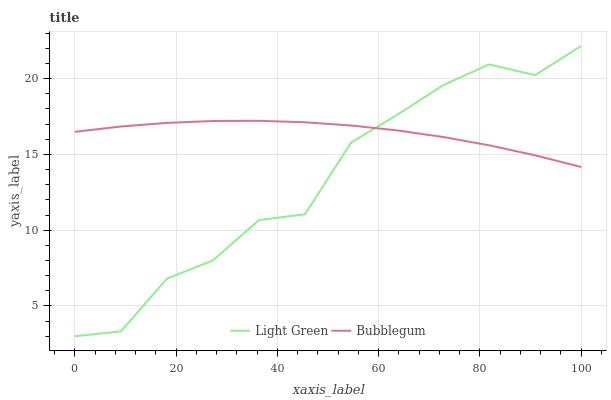Does Light Green have the minimum area under the curve?
Answer yes or no. Yes. Does Bubblegum have the maximum area under the curve?
Answer yes or no. Yes. Does Light Green have the maximum area under the curve?
Answer yes or no. No. Is Bubblegum the smoothest?
Answer yes or no. Yes. Is Light Green the roughest?
Answer yes or no. Yes. Is Light Green the smoothest?
Answer yes or no. No. Does Light Green have the lowest value?
Answer yes or no. Yes. Does Light Green have the highest value?
Answer yes or no. Yes. Does Bubblegum intersect Light Green?
Answer yes or no. Yes. Is Bubblegum less than Light Green?
Answer yes or no. No. Is Bubblegum greater than Light Green?
Answer yes or no. No. 